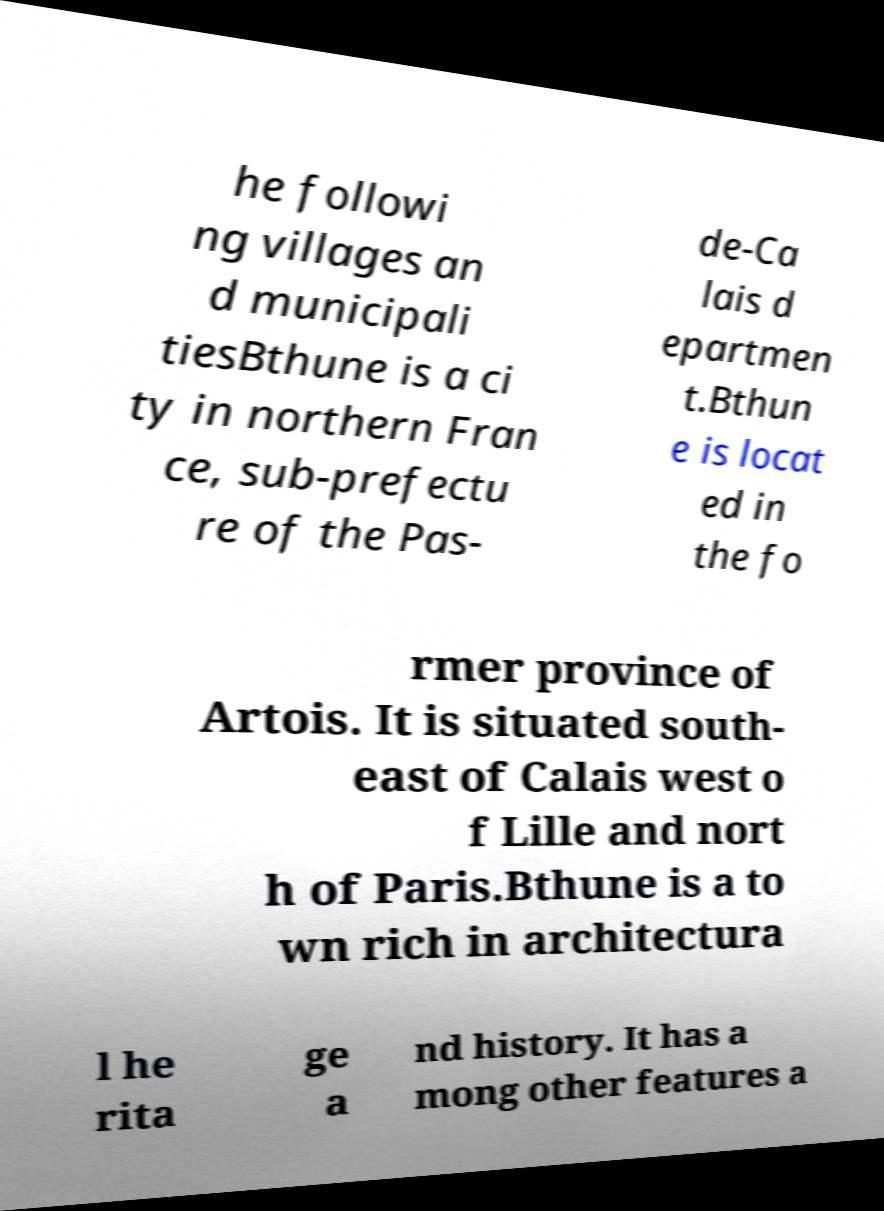There's text embedded in this image that I need extracted. Can you transcribe it verbatim? he followi ng villages an d municipali tiesBthune is a ci ty in northern Fran ce, sub-prefectu re of the Pas- de-Ca lais d epartmen t.Bthun e is locat ed in the fo rmer province of Artois. It is situated south- east of Calais west o f Lille and nort h of Paris.Bthune is a to wn rich in architectura l he rita ge a nd history. It has a mong other features a 